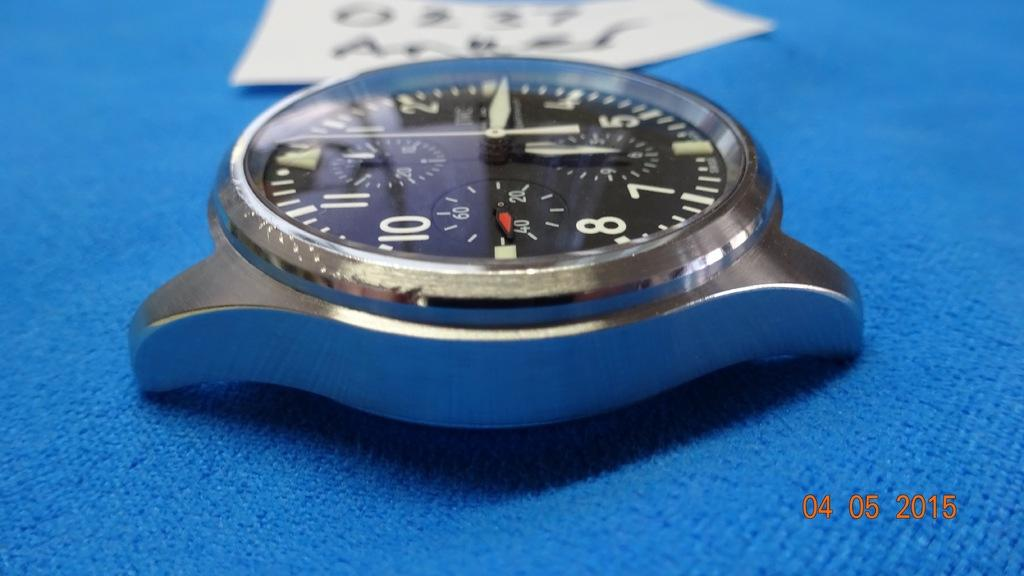<image>
Offer a succinct explanation of the picture presented. A wristwatch without a band is lying on a blue cloth, as documented in the year 2015. 